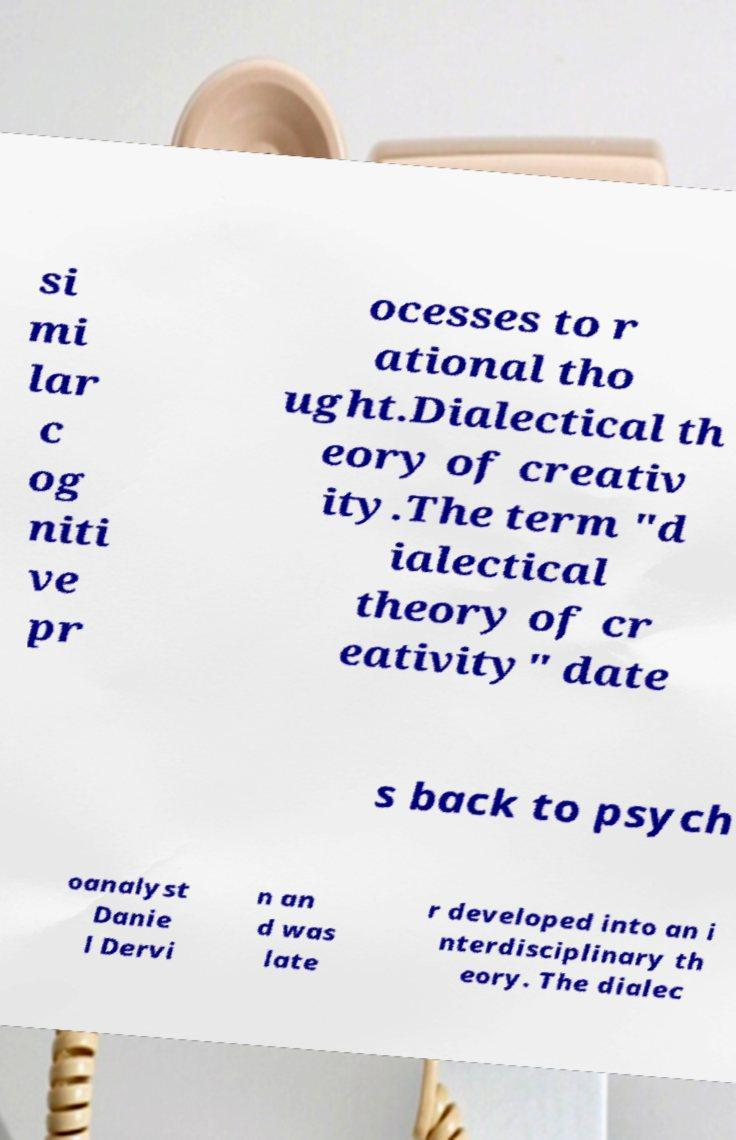Can you accurately transcribe the text from the provided image for me? si mi lar c og niti ve pr ocesses to r ational tho ught.Dialectical th eory of creativ ity.The term "d ialectical theory of cr eativity" date s back to psych oanalyst Danie l Dervi n an d was late r developed into an i nterdisciplinary th eory. The dialec 